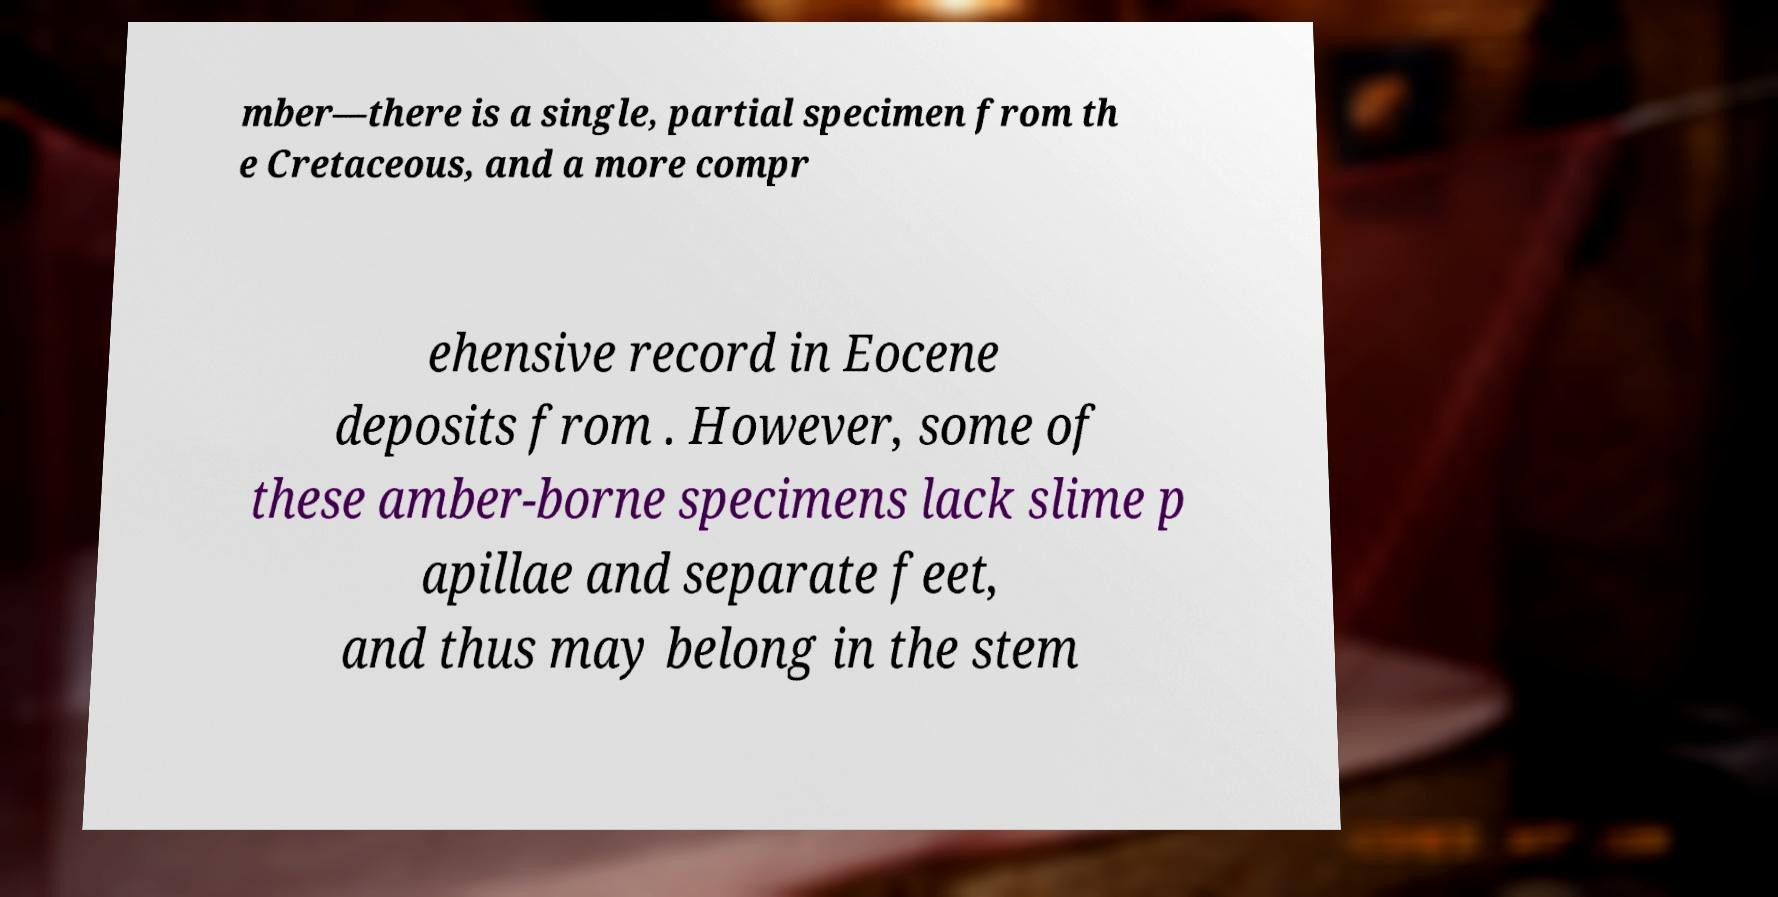There's text embedded in this image that I need extracted. Can you transcribe it verbatim? mber—there is a single, partial specimen from th e Cretaceous, and a more compr ehensive record in Eocene deposits from . However, some of these amber-borne specimens lack slime p apillae and separate feet, and thus may belong in the stem 